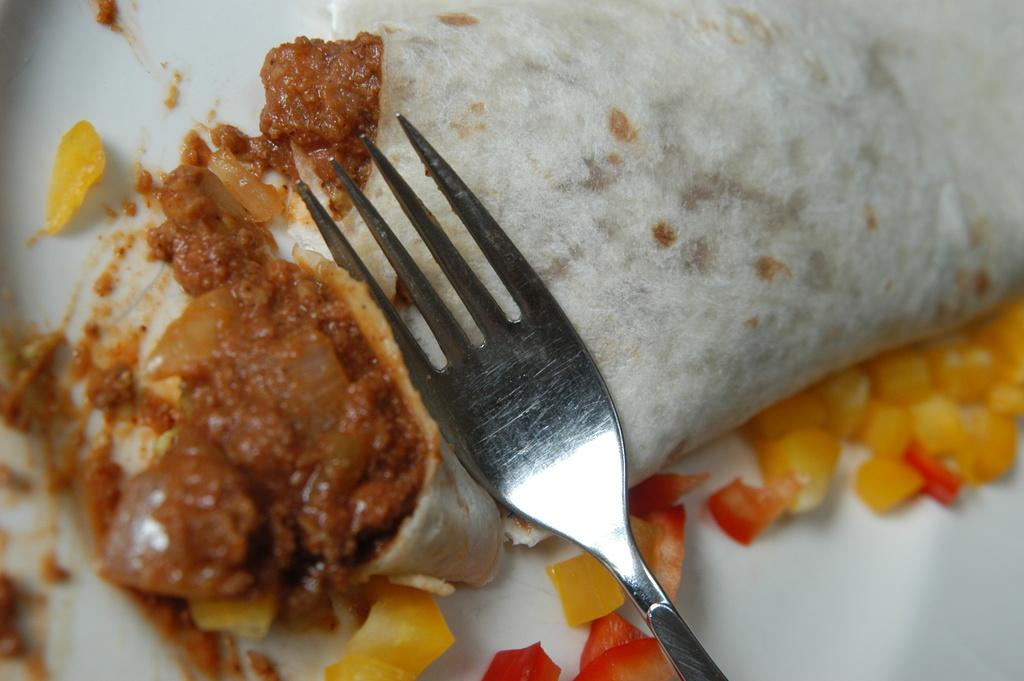What utensil can be seen in the image? There is a fork in the image. On what is the fork placed? The fork is on an object. What type of food is on the object? There is curry on the object. What other food items are visible in the image? There are other food items on a white color plate. Can you see a quarter in the image? There is no quarter present in the image. Are there any eyes visible in the image? There are no eyes visible in the image. 